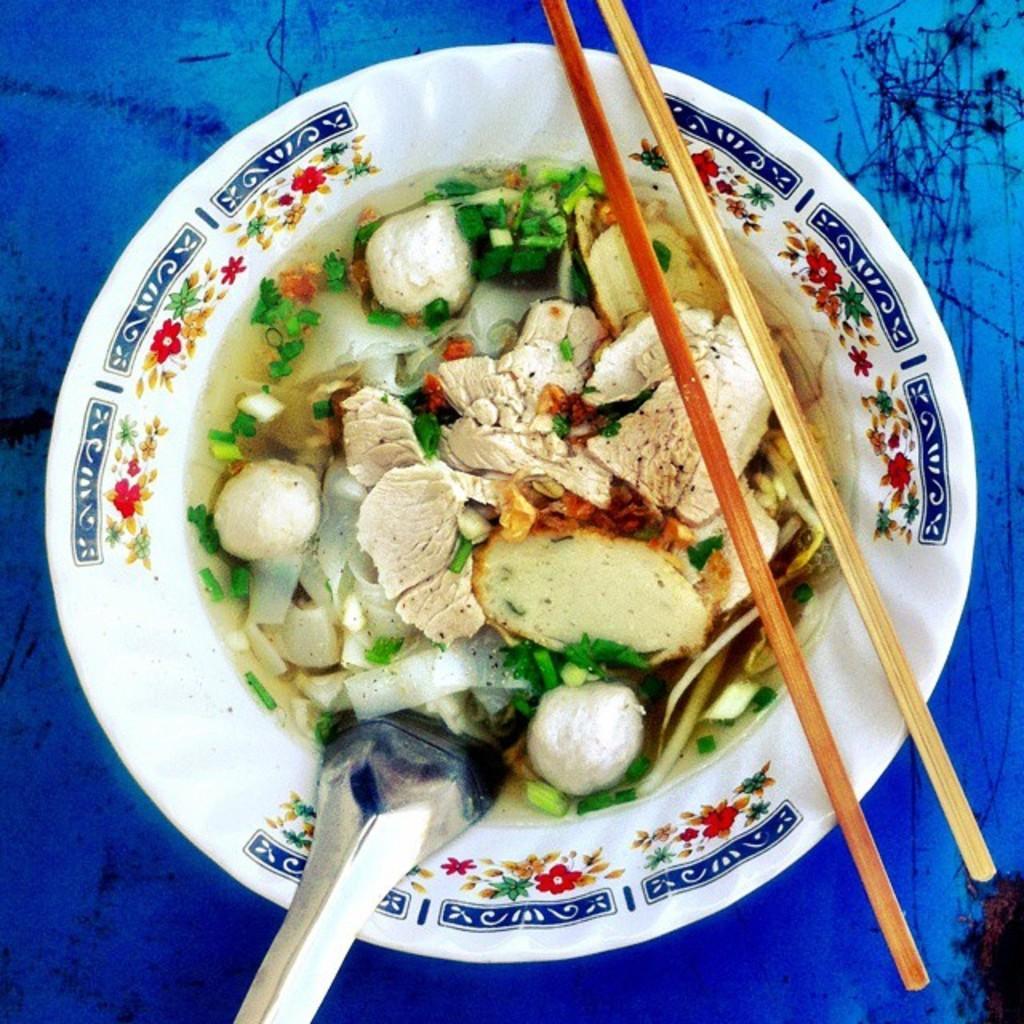Can you describe this image briefly? In the image in the center we can see some food item in the bowl and we can see the spoon. 